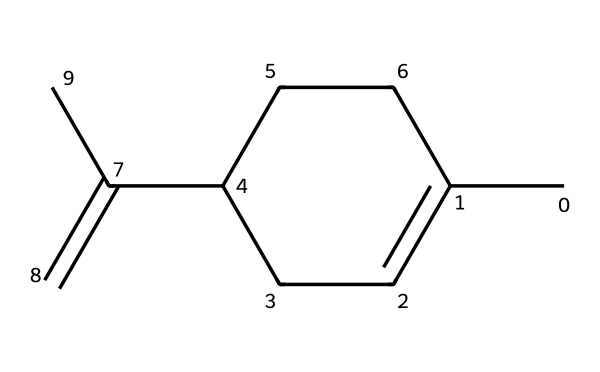What is the molecular formula of limonene? To determine the molecular formula, count the carbon (C) and hydrogen (H) atoms in the structure. The unique chiral and linear structures indicate 10 carbon atoms and 16 hydrogen atoms, leading to the formula C10H16.
Answer: C10H16 How many chiral centers are present in limonene? Examine the structure for chiral centers, which are carbon atoms bonded to four different substituents. Limonene has one such carbon atom, indicating it's chiral.
Answer: one What type of chemical compound is limonene classified as? Based on its structure, limonene is a hydrocarbon (specifically a terpenoid), which consists of hydrogen and carbon atoms primarily, with a cyclic part denoting its classification.
Answer: terpenoid Which functional group is primarily present in limonene? Limonene's structure shows it is composed mainly of carbon and hydrogen, lacking polar functional groups like alcohol or acid, thus it is categorized under hydrocarbons.
Answer: hydrocarbon Does limonene exhibit optical activity? Since limonene contains a chiral center, it can exist in two enantiomeric forms which rotate polarized light differently, confirming its optical activity.
Answer: yes What natural sources commonly contain limonene? Limonene is predominantly found in citrus fruit peels, especially oranges or lemons, due to its high concentration in the essential oils extracted from these sources.
Answer: citrus fruits How many double bonds are present in limonene? By analyzing the structure, limonene contains one double bond between two carbon atoms, which contributes to its unsaturated nature.
Answer: one 